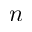Convert formula to latex. <formula><loc_0><loc_0><loc_500><loc_500>n</formula> 